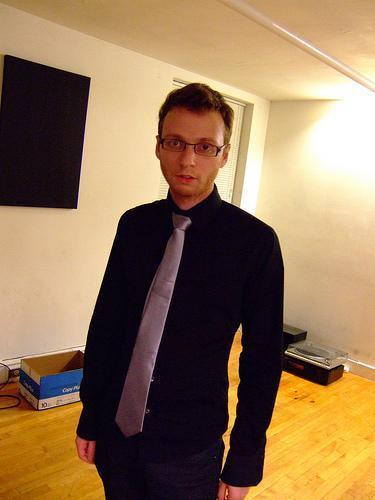How many people are in the photo?
Give a very brief answer. 1. 